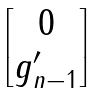Convert formula to latex. <formula><loc_0><loc_0><loc_500><loc_500>\begin{bmatrix} 0 \\ g _ { n - 1 } ^ { \prime } \end{bmatrix}</formula> 